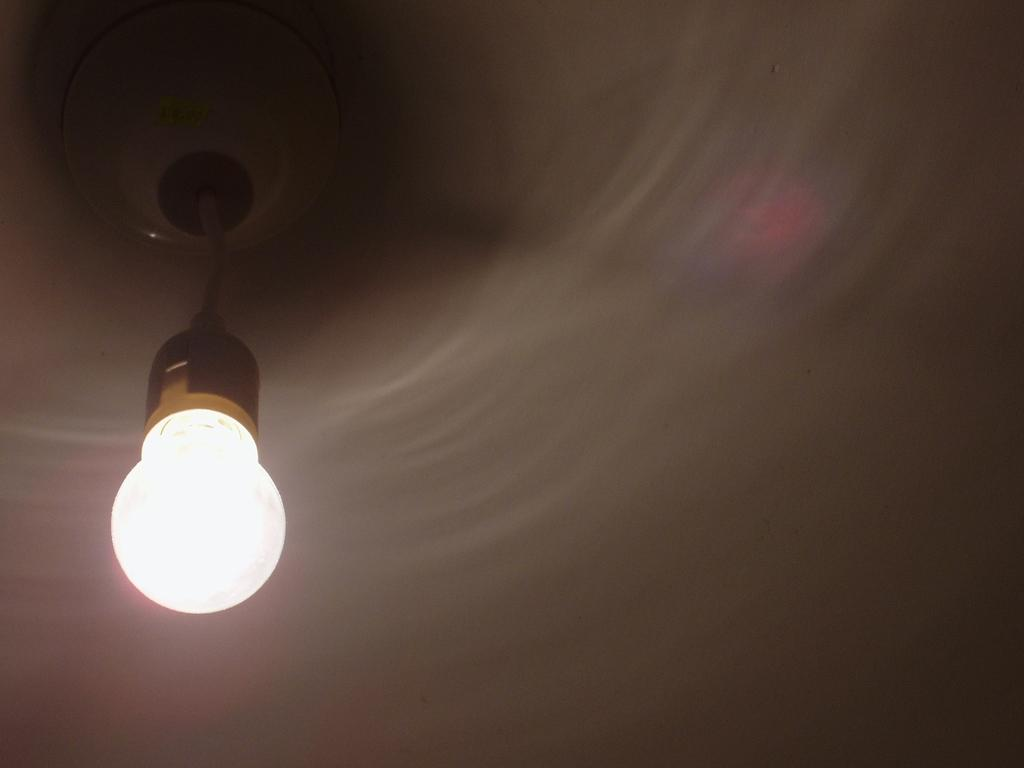What can be seen in the image that provides illumination? There is a light in the image. What color is the background of the image? The background of the image is white. What is the purpose of the heart in the image? There is no heart present in the image, so it cannot be determined what its purpose might be. 